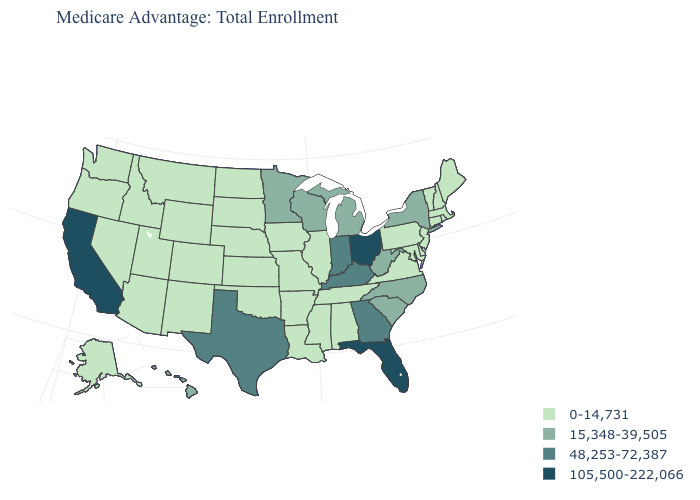Name the states that have a value in the range 15,348-39,505?
Short answer required. Hawaii, Michigan, Minnesota, North Carolina, New York, South Carolina, Wisconsin, West Virginia. What is the value of Hawaii?
Keep it brief. 15,348-39,505. Which states have the highest value in the USA?
Quick response, please. California, Florida, Ohio. Which states have the highest value in the USA?
Answer briefly. California, Florida, Ohio. Which states have the highest value in the USA?
Write a very short answer. California, Florida, Ohio. What is the value of Idaho?
Be succinct. 0-14,731. What is the value of Minnesota?
Write a very short answer. 15,348-39,505. Name the states that have a value in the range 48,253-72,387?
Quick response, please. Georgia, Indiana, Kentucky, Texas. Does the map have missing data?
Keep it brief. No. Which states have the lowest value in the South?
Give a very brief answer. Alabama, Arkansas, Delaware, Louisiana, Maryland, Mississippi, Oklahoma, Tennessee, Virginia. Which states hav the highest value in the South?
Concise answer only. Florida. What is the value of Florida?
Quick response, please. 105,500-222,066. Is the legend a continuous bar?
Give a very brief answer. No. What is the highest value in the USA?
Concise answer only. 105,500-222,066. 